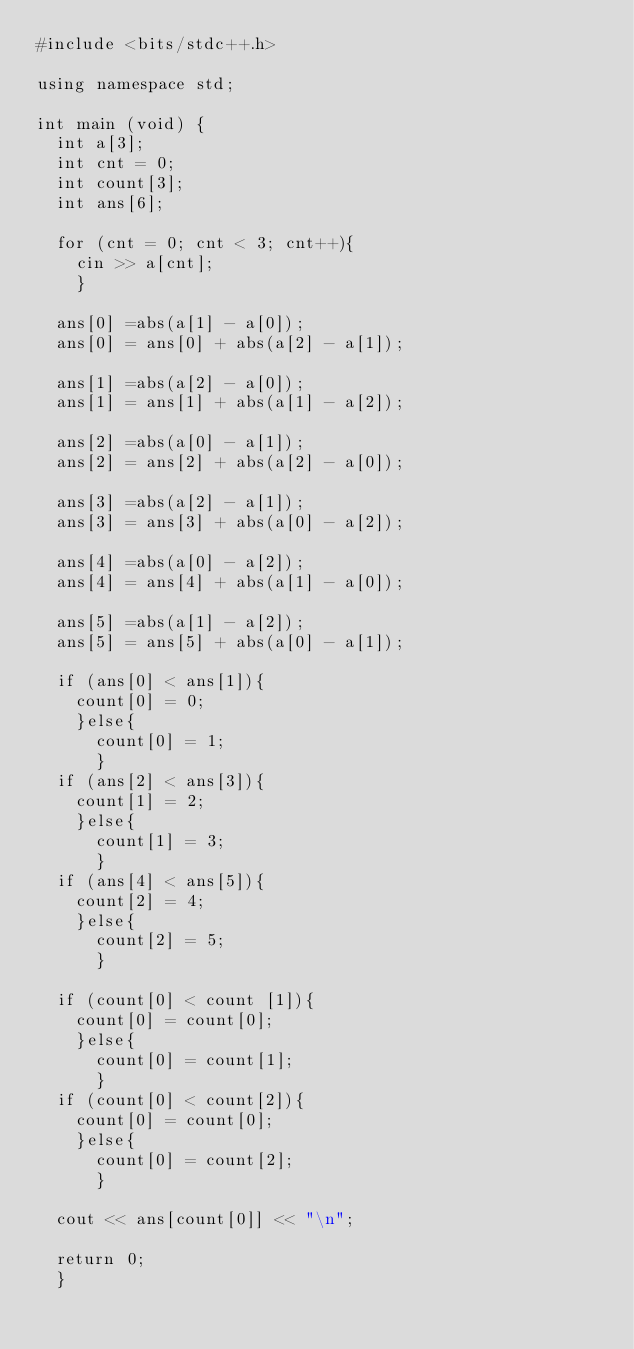<code> <loc_0><loc_0><loc_500><loc_500><_C++_>#include <bits/stdc++.h>

using namespace std;

int main (void) {
	int a[3];
	int cnt = 0;
	int count[3];
	int ans[6];
	
	for (cnt = 0; cnt < 3; cnt++){
		cin >> a[cnt];
		}
		
	ans[0] =abs(a[1] - a[0]);
	ans[0] = ans[0] + abs(a[2] - a[1]);
	
	ans[1] =abs(a[2] - a[0]);
	ans[1] = ans[1] + abs(a[1] - a[2]);
	
	ans[2] =abs(a[0] - a[1]);
	ans[2] = ans[2] + abs(a[2] - a[0]);

	ans[3] =abs(a[2] - a[1]);
	ans[3] = ans[3] + abs(a[0] - a[2]);
	
	ans[4] =abs(a[0] - a[2]);
	ans[4] = ans[4] + abs(a[1] - a[0]);
	
	ans[5] =abs(a[1] - a[2]);
	ans[5] = ans[5] + abs(a[0] - a[1]);
	
	if (ans[0] < ans[1]){
		count[0] = 0;
		}else{
			count[0] = 1;
			}
	if (ans[2] < ans[3]){
		count[1] = 2;
		}else{
			count[1] = 3;
			}
	if (ans[4] < ans[5]){
		count[2] = 4;
		}else{
			count[2] = 5;
			}
			
	if (count[0] < count [1]){
		count[0] = count[0];
		}else{
			count[0] = count[1];
			}
	if (count[0] < count[2]){
		count[0] = count[0];
		}else{
			count[0] = count[2];
			}
			
	cout << ans[count[0]] << "\n";
	
	return 0;
	}</code> 